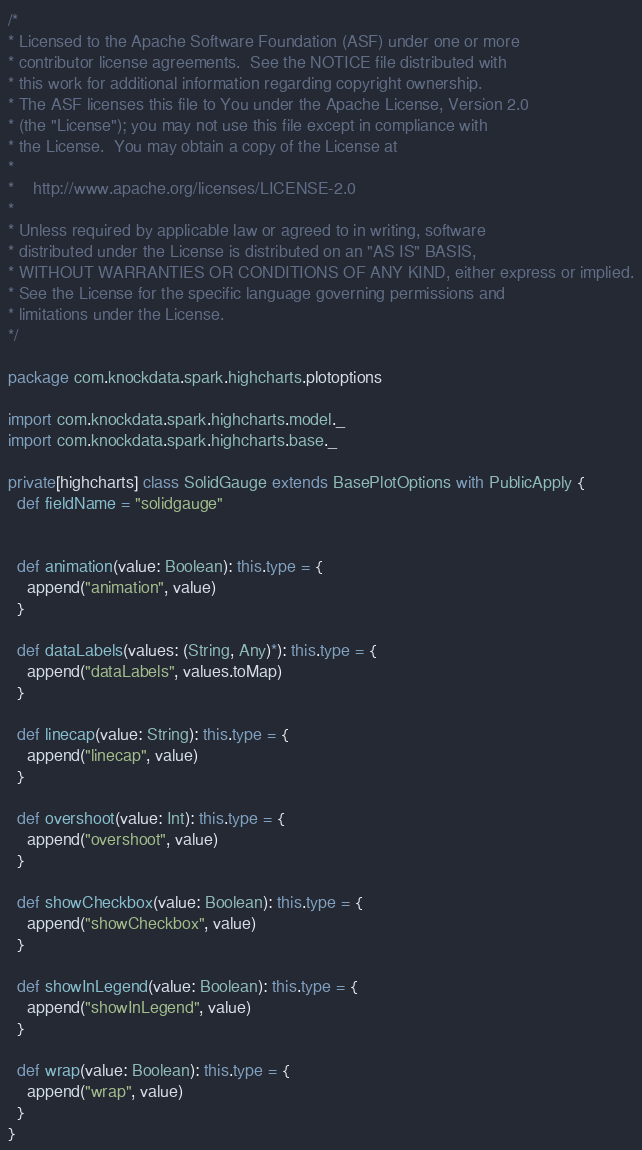Convert code to text. <code><loc_0><loc_0><loc_500><loc_500><_Scala_>/*
* Licensed to the Apache Software Foundation (ASF) under one or more
* contributor license agreements.  See the NOTICE file distributed with
* this work for additional information regarding copyright ownership.
* The ASF licenses this file to You under the Apache License, Version 2.0
* (the "License"); you may not use this file except in compliance with
* the License.  You may obtain a copy of the License at
*
*    http://www.apache.org/licenses/LICENSE-2.0
*
* Unless required by applicable law or agreed to in writing, software
* distributed under the License is distributed on an "AS IS" BASIS,
* WITHOUT WARRANTIES OR CONDITIONS OF ANY KIND, either express or implied.
* See the License for the specific language governing permissions and
* limitations under the License.
*/

package com.knockdata.spark.highcharts.plotoptions

import com.knockdata.spark.highcharts.model._
import com.knockdata.spark.highcharts.base._

private[highcharts] class SolidGauge extends BasePlotOptions with PublicApply {
  def fieldName = "solidgauge"


  def animation(value: Boolean): this.type = {
    append("animation", value)
  }

  def dataLabels(values: (String, Any)*): this.type = {
    append("dataLabels", values.toMap)
  }

  def linecap(value: String): this.type = {
    append("linecap", value)
  }

  def overshoot(value: Int): this.type = {
    append("overshoot", value)
  }

  def showCheckbox(value: Boolean): this.type = {
    append("showCheckbox", value)
  }

  def showInLegend(value: Boolean): this.type = {
    append("showInLegend", value)
  }

  def wrap(value: Boolean): this.type = {
    append("wrap", value)
  }
}
</code> 